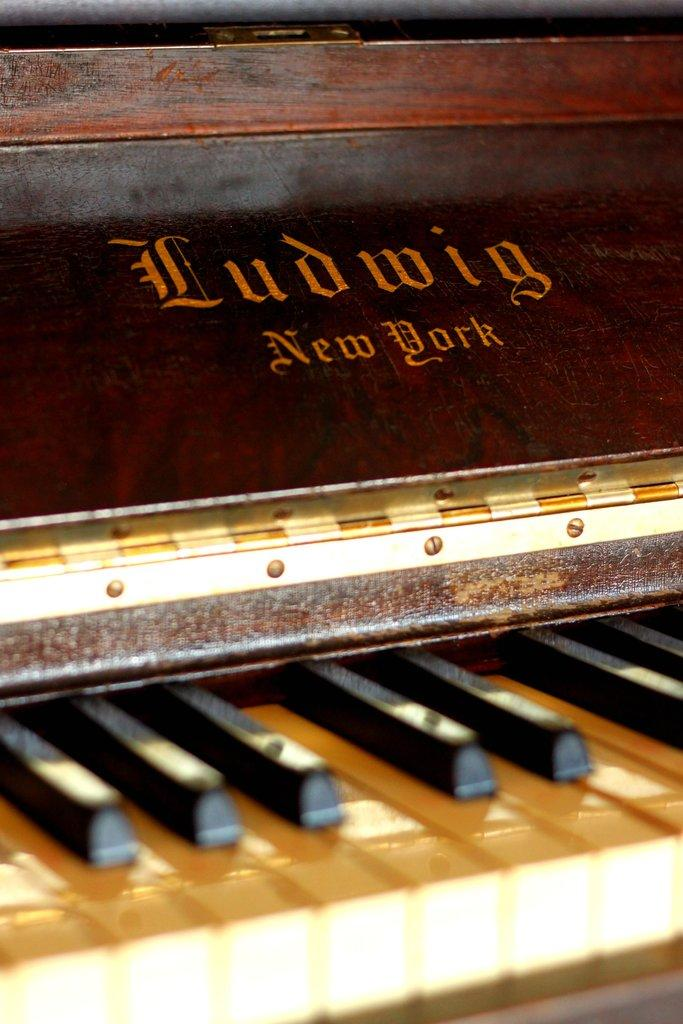What type of musical instrument is represented in the image? The image features piano keys. What colors are the piano keys? The piano keys are black and white in color. What material is used to construct the frame around the piano keys? The frame is made of wood. What name is given to the wooden frame in the image? The wooden frame is named "LUDWIG new york." What type of process is depicted in the image? There is no process depicted in the image; it features piano keys and a wooden frame. Can you see a stream in the image? No, there is no stream visible in the image. 